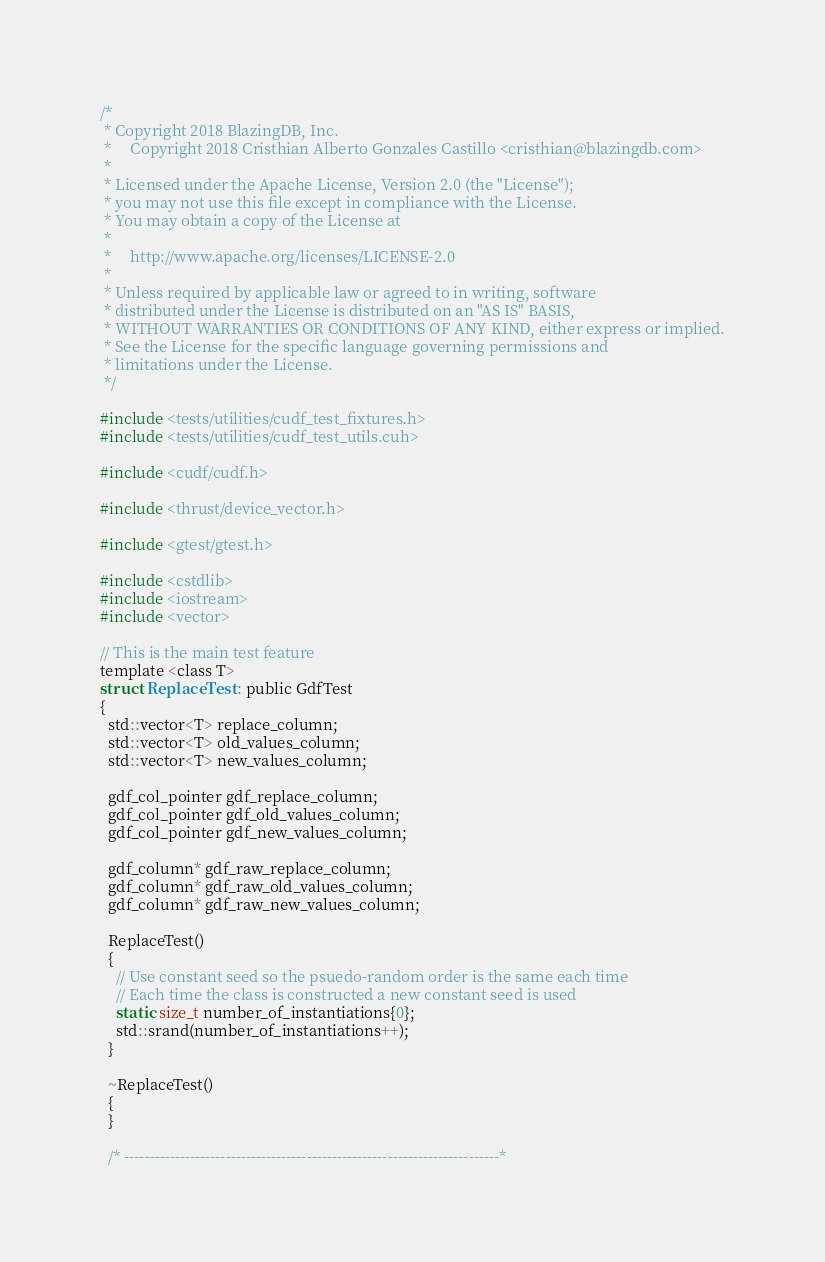<code> <loc_0><loc_0><loc_500><loc_500><_Cuda_>/*
 * Copyright 2018 BlazingDB, Inc.
 *     Copyright 2018 Cristhian Alberto Gonzales Castillo <cristhian@blazingdb.com>
 *
 * Licensed under the Apache License, Version 2.0 (the "License");
 * you may not use this file except in compliance with the License.
 * You may obtain a copy of the License at
 *
 *     http://www.apache.org/licenses/LICENSE-2.0
 *
 * Unless required by applicable law or agreed to in writing, software
 * distributed under the License is distributed on an "AS IS" BASIS,
 * WITHOUT WARRANTIES OR CONDITIONS OF ANY KIND, either express or implied.
 * See the License for the specific language governing permissions and
 * limitations under the License.
 */

#include <tests/utilities/cudf_test_fixtures.h>
#include <tests/utilities/cudf_test_utils.cuh>

#include <cudf/cudf.h>

#include <thrust/device_vector.h>

#include <gtest/gtest.h>

#include <cstdlib>
#include <iostream>
#include <vector>

// This is the main test feature
template <class T>
struct ReplaceTest : public GdfTest
{
  std::vector<T> replace_column;
  std::vector<T> old_values_column;
  std::vector<T> new_values_column;

  gdf_col_pointer gdf_replace_column;
  gdf_col_pointer gdf_old_values_column;
  gdf_col_pointer gdf_new_values_column;

  gdf_column* gdf_raw_replace_column;
  gdf_column* gdf_raw_old_values_column;
  gdf_column* gdf_raw_new_values_column;

  ReplaceTest()
  {
    // Use constant seed so the psuedo-random order is the same each time
    // Each time the class is constructed a new constant seed is used
    static size_t number_of_instantiations{0};
    std::srand(number_of_instantiations++);
  }

  ~ReplaceTest()
  {
  }

  /* --------------------------------------------------------------------------*</code> 